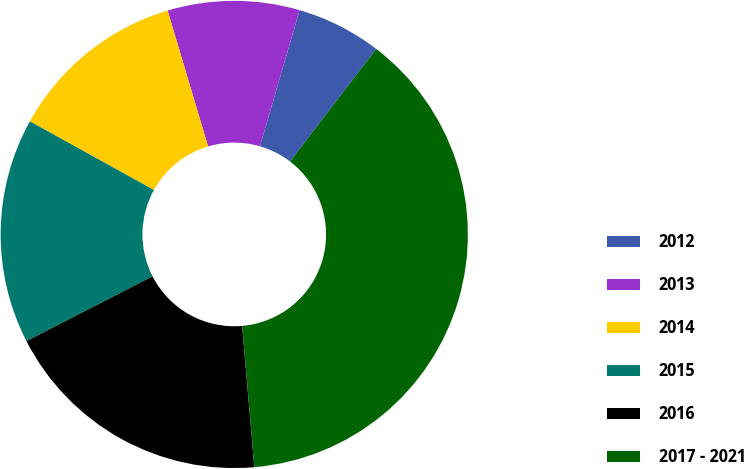Convert chart to OTSL. <chart><loc_0><loc_0><loc_500><loc_500><pie_chart><fcel>2012<fcel>2013<fcel>2014<fcel>2015<fcel>2016<fcel>2017 - 2021<nl><fcel>5.88%<fcel>9.12%<fcel>12.35%<fcel>15.59%<fcel>18.82%<fcel>38.23%<nl></chart> 